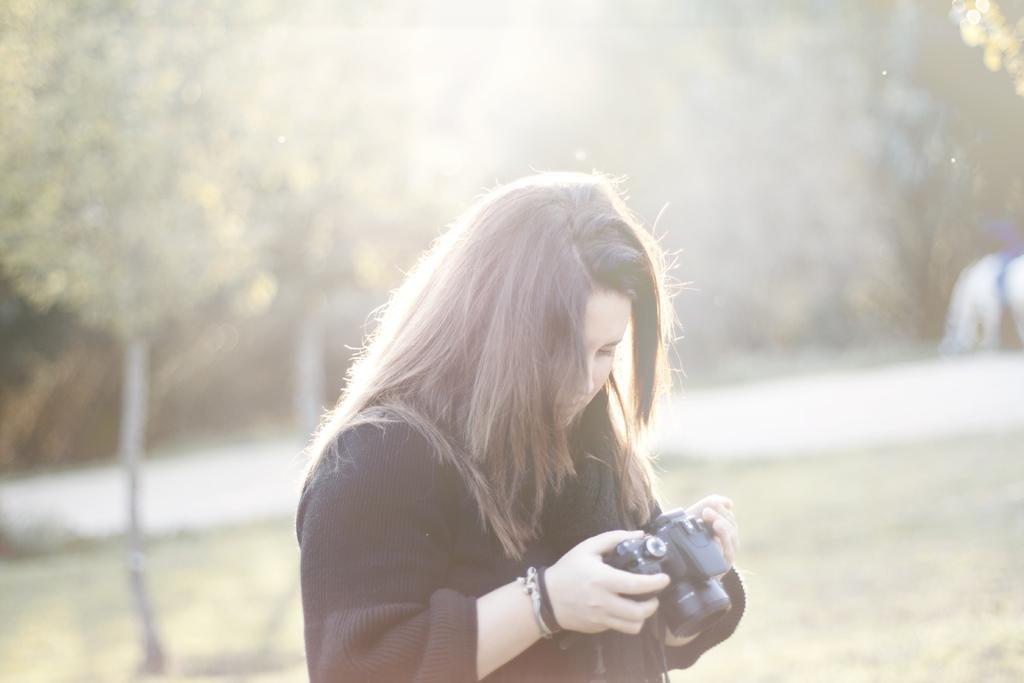How would you summarize this image in a sentence or two? In this image we can see many trees. We can see a person holding a camera in the image. There is a grassy land in the image. 